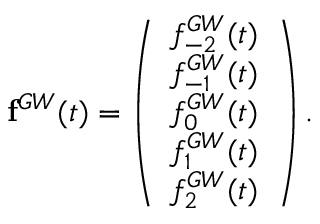Convert formula to latex. <formula><loc_0><loc_0><loc_500><loc_500>{ f } ^ { G W } ( t ) = \left ( \begin{array} { l } { f _ { - 2 } ^ { G W } ( t ) } \\ { f _ { - 1 } ^ { G W } ( t ) } \\ { f _ { 0 } ^ { G W } ( t ) } \\ { f _ { 1 } ^ { G W } ( t ) } \\ { f _ { 2 } ^ { G W } ( t ) } \end{array} \right ) .</formula> 